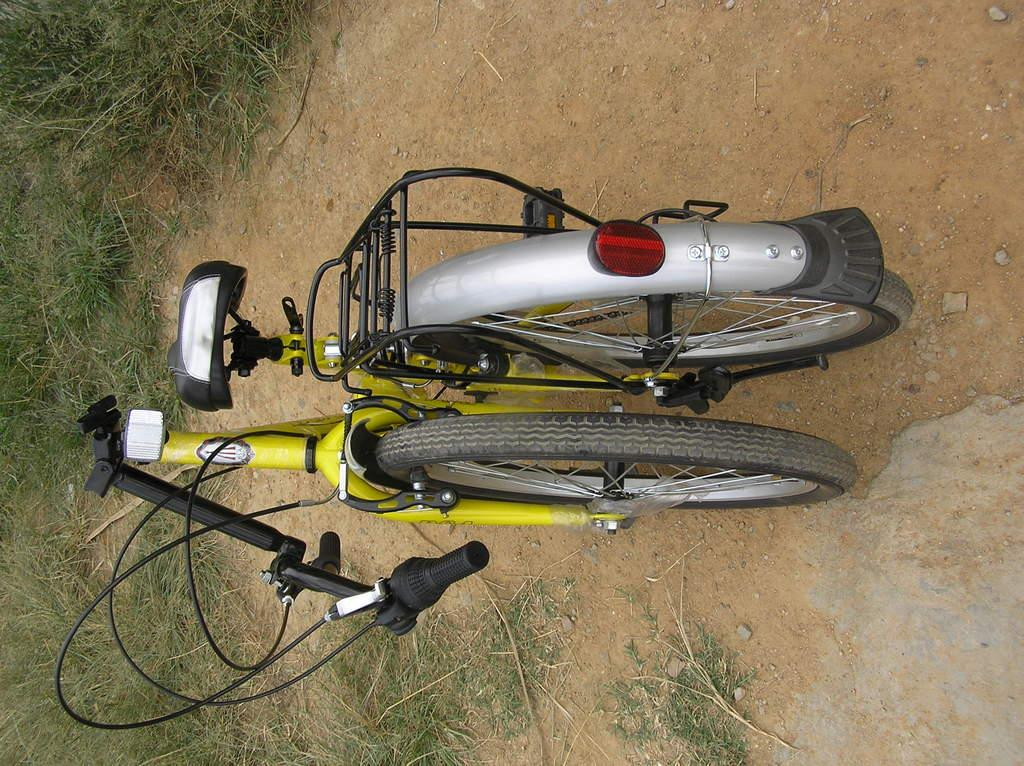What type of terrain is visible in the image? There is a land visible in the image. What object can be seen on the land? There is a bicycle on the land. How many times does the zephyr sneeze in the image? There is no mention of a zephyr or sneezing in the image, as it only features a land and a bicycle. 